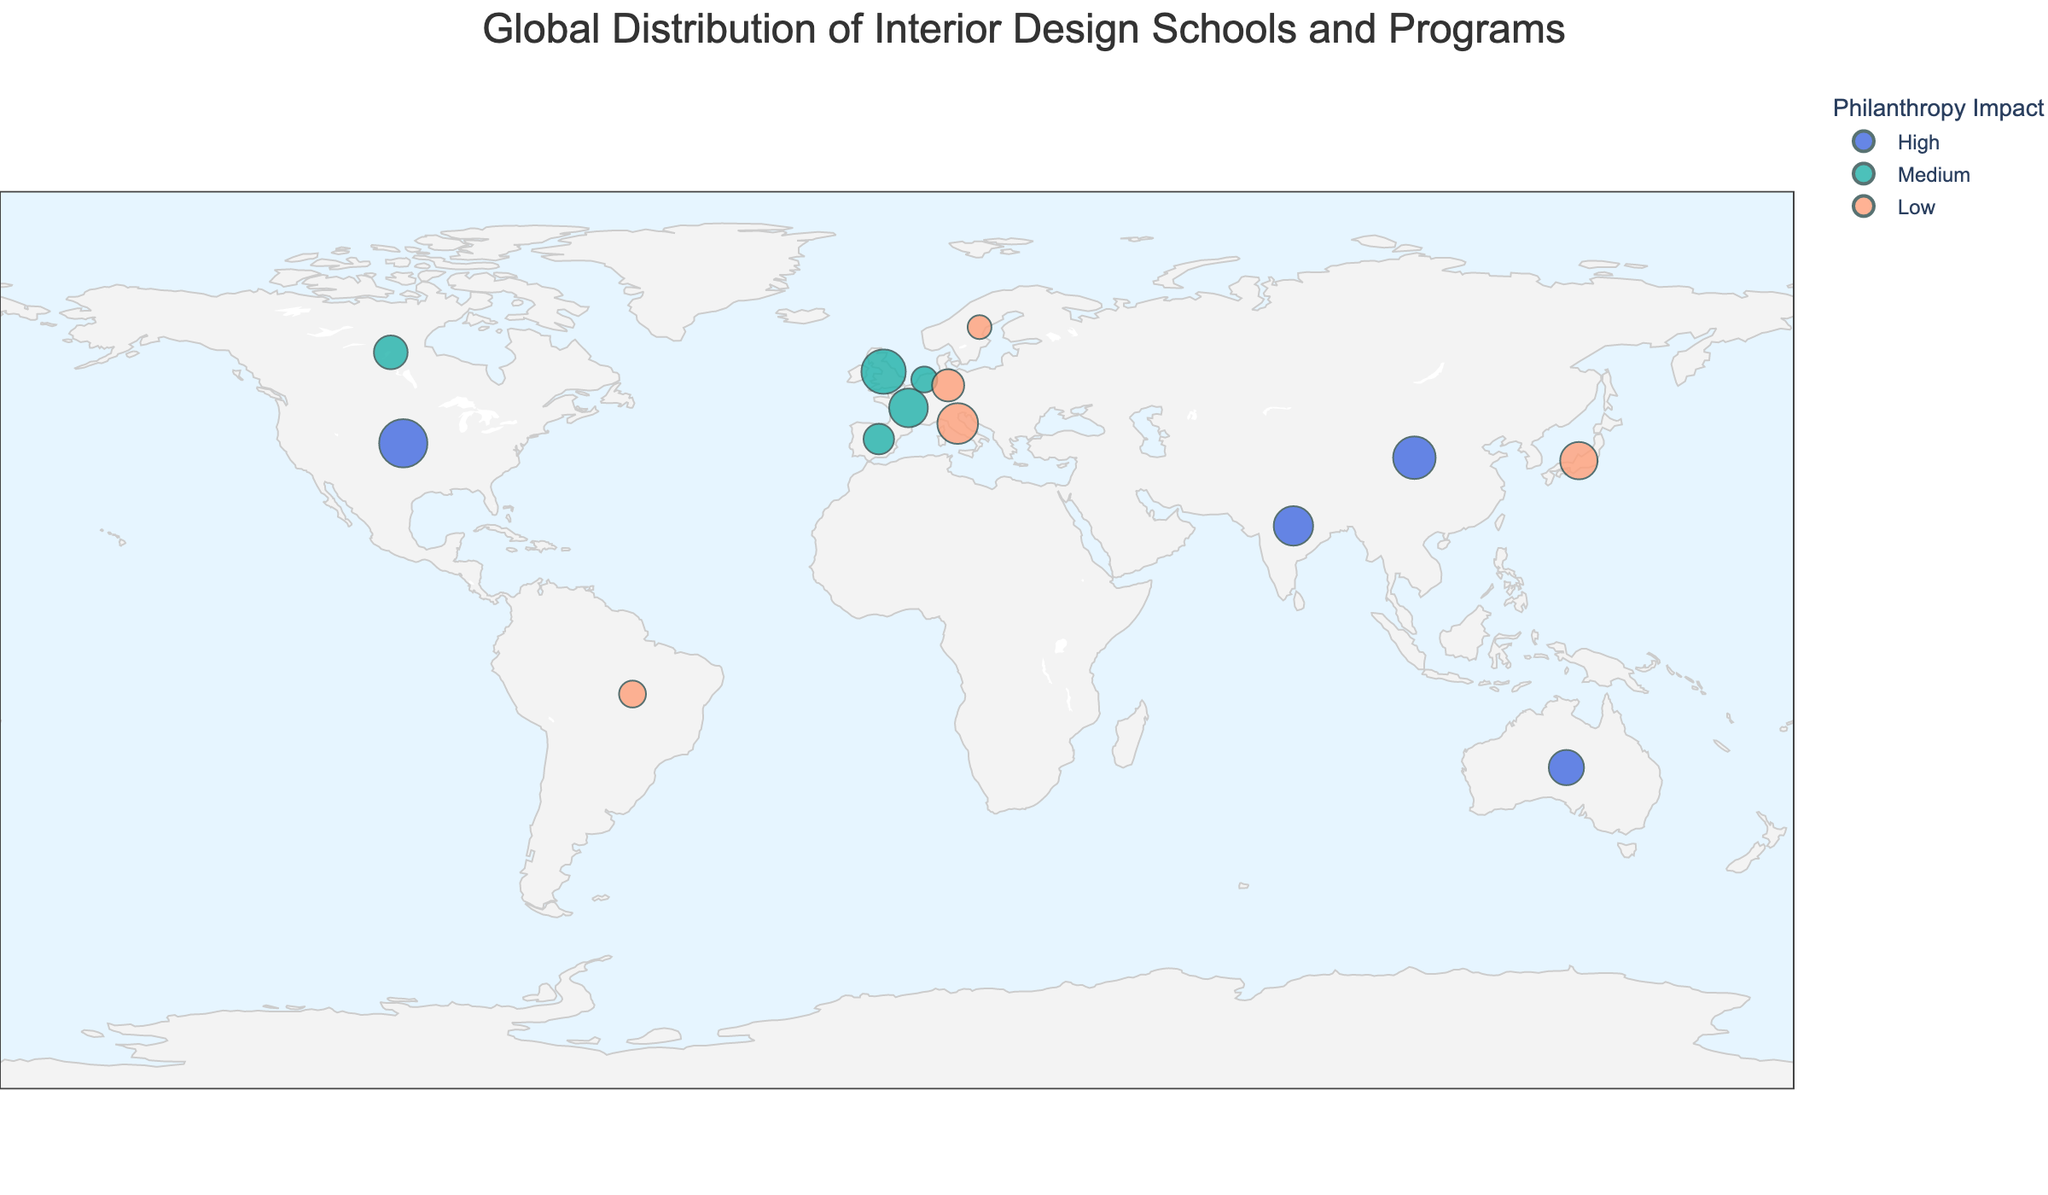Which country has the highest number of students enrolled in interior design programs? Examine the sizes of the markers in each country on the map. The largest marker corresponds to the USA (New York, Parsons School of Design) with a student count of 450.
Answer: USA What is the title of the figure? Look at the main text at the top of the figure, which indicates the overall subject. It reads "Global Distribution of Interior Design Schools and Programs."
Answer: Global Distribution of Interior Design Schools and Programs How many schools have a high philanthropy impact? Identify the markers colored as '#4169E1' (the color for "High" philanthropy impact). There are five such markers in the USA, Australia, China, Singapore, and India.
Answer: 5 Which school's program has the smallest student enrollment and in which country is it located? Find the smallest marker on the map, which is found in Sweden (Stockholm, Beckmans College of Design) with 110 students.
Answer: Sweden, Beckmans College of Design What is the difference in student count between the largest and smallest programs? Identify the largest program (Parsons School of Design with 450 students) and the smallest program (Beckmans College of Design with 110 students). Subtract the smaller number from the larger number, i.e., 450 - 110 = 340.
Answer: 340 Which city outside of the USA has the largest number of students in an interior design program? Compare the sizes of the markers outside the USA. The largest marker corresponds to London (University of the Arts London) with 380 students.
Answer: London What is the common feature of the countries with a high philanthropy impact? Locate the countries with markers colored '#4169E1' (High philanthropy impact). These countries span multiple continents and include the USA, Australia, China, Singapore, and India. The common feature is they are all major global cities.
Answer: Major global cities What proportion of the programs have a medium philanthropy impact? Count the number of schools with markers colored '#20B2AA' (Medium philanthropy impact) – there are 6. There are 15 schools in total. The proportion is calculated as 6/15, which is equivalent to 0.4, or 40%.
Answer: 40% Which continent has the most interior design programs represented on the map? Observe the distribution of markers across continents. Europe has the most markers, with schools in the UK, Italy, France, Germany, Spain, Netherlands, and Sweden, totaling 7 schools.
Answer: Europe 